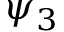Convert formula to latex. <formula><loc_0><loc_0><loc_500><loc_500>\psi _ { 3 }</formula> 